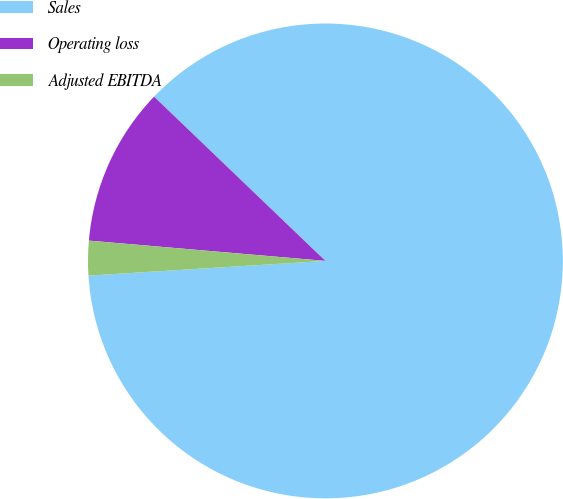<chart> <loc_0><loc_0><loc_500><loc_500><pie_chart><fcel>Sales<fcel>Operating loss<fcel>Adjusted EBITDA<nl><fcel>86.85%<fcel>10.8%<fcel>2.35%<nl></chart> 